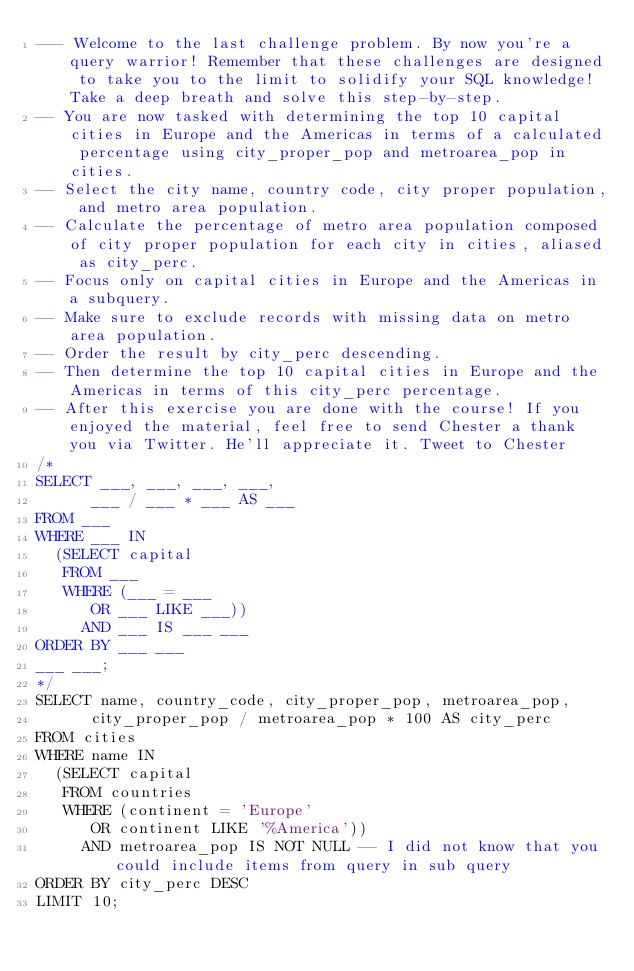Convert code to text. <code><loc_0><loc_0><loc_500><loc_500><_SQL_>--- Welcome to the last challenge problem. By now you're a query warrior! Remember that these challenges are designed to take you to the limit to solidify your SQL knowledge! Take a deep breath and solve this step-by-step.
-- You are now tasked with determining the top 10 capital cities in Europe and the Americas in terms of a calculated percentage using city_proper_pop and metroarea_pop in cities.
-- Select the city name, country code, city proper population, and metro area population.
-- Calculate the percentage of metro area population composed of city proper population for each city in cities, aliased as city_perc.
-- Focus only on capital cities in Europe and the Americas in a subquery.
-- Make sure to exclude records with missing data on metro area population.
-- Order the result by city_perc descending.
-- Then determine the top 10 capital cities in Europe and the Americas in terms of this city_perc percentage.
-- After this exercise you are done with the course! If you enjoyed the material, feel free to send Chester a thank you via Twitter. He'll appreciate it. Tweet to Chester
/*
SELECT ___, ___, ___, ___,
      ___ / ___ * ___ AS ___
FROM ___
WHERE ___ IN
  (SELECT capital
   FROM ___
   WHERE (___ = ___
      OR ___ LIKE ___))
     AND ___ IS ___ ___
ORDER BY ___ ___
___ ___;
*/
SELECT name, country_code, city_proper_pop, metroarea_pop,
      city_proper_pop / metroarea_pop * 100 AS city_perc
FROM cities
WHERE name IN
  (SELECT capital
   FROM countries
   WHERE (continent = 'Europe'
      OR continent LIKE '%America'))
     AND metroarea_pop IS NOT NULL -- I did not know that you could include items from query in sub query 
ORDER BY city_perc DESC
LIMIT 10;</code> 